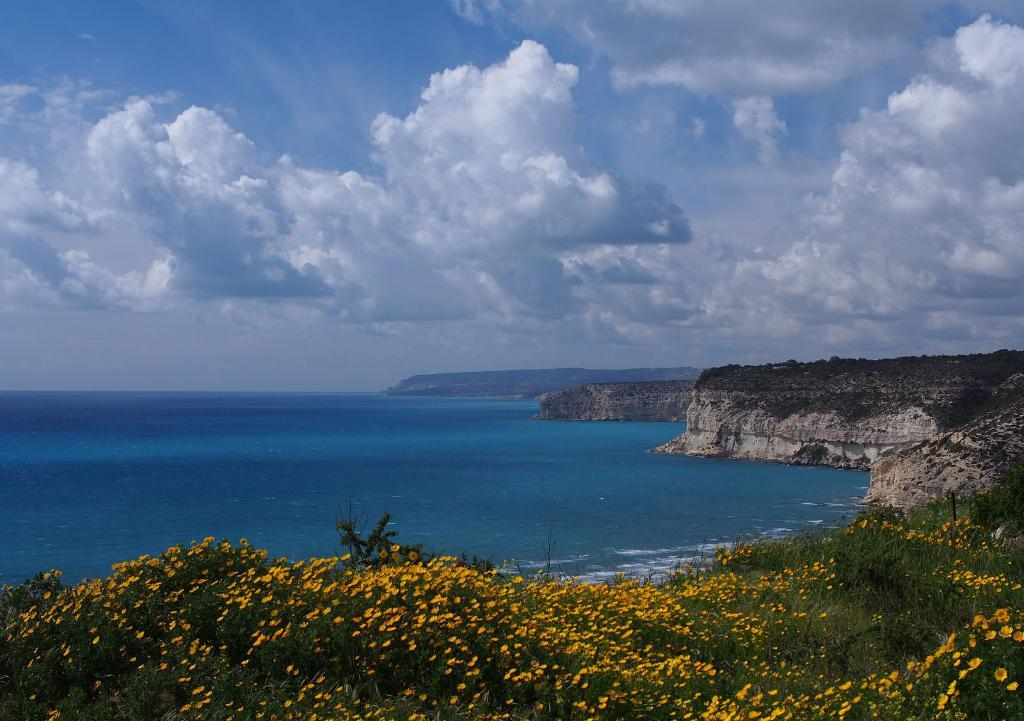What type of plants can be seen in the image? There are flower plants in the image. What natural features are present in the image? There are hills and water visible in the image. How would you describe the sky in the image? The sky is cloudy in the image. What type of crayon can be seen melting in the water in the image? There is no crayon present in the image, and therefore no such activity can be observed. 